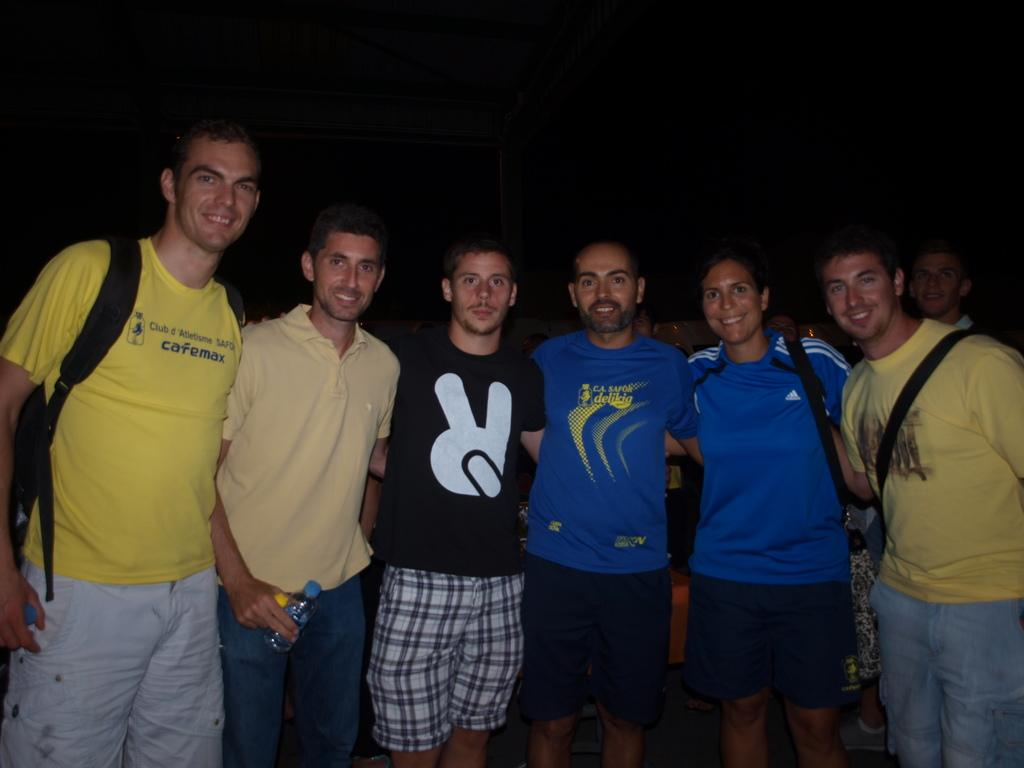What is happening with the group of people in the image? The people in the image are standing, seeing, and smiling. What are some people wearing in the image? Some people are wearing bags in the image. What are some people holding in the image? Some people are holding objects in the image. How would you describe the background of the image? The background has a dark view. Are there any flowers or cobwebs visible in the image? No, there are no flowers or cobwebs present in the image. 